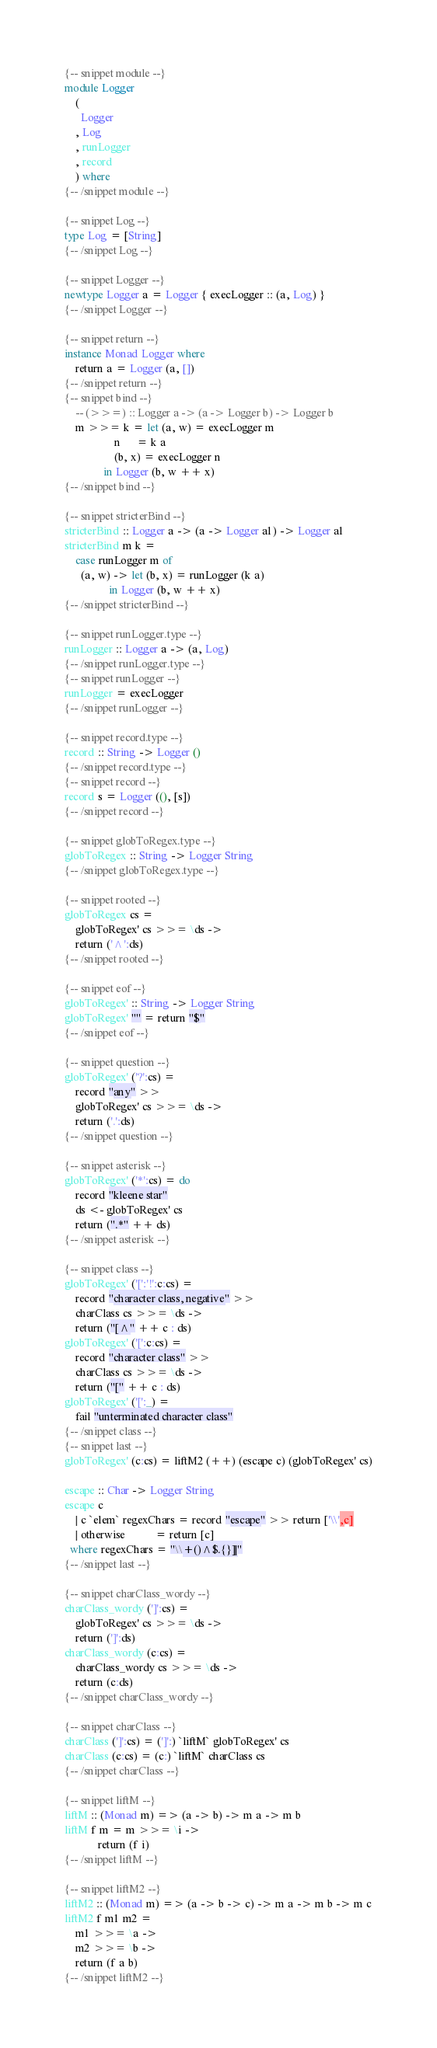Convert code to text. <code><loc_0><loc_0><loc_500><loc_500><_Haskell_>{-- snippet module --}
module Logger
    (
      Logger
    , Log
    , runLogger
    , record
    ) where
{-- /snippet module --}

{-- snippet Log --}
type Log = [String]
{-- /snippet Log --}

{-- snippet Logger --}
newtype Logger a = Logger { execLogger :: (a, Log) }
{-- /snippet Logger --}

{-- snippet return --}
instance Monad Logger where
    return a = Logger (a, [])
{-- /snippet return --}
{-- snippet bind --}
    -- (>>=) :: Logger a -> (a -> Logger b) -> Logger b
    m >>= k = let (a, w) = execLogger m
                  n      = k a
                  (b, x) = execLogger n
              in Logger (b, w ++ x)
{-- /snippet bind --}

{-- snippet stricterBind --}
stricterBind :: Logger a -> (a -> Logger a1) -> Logger a1
stricterBind m k =
    case runLogger m of
      (a, w) -> let (b, x) = runLogger (k a)
                in Logger (b, w ++ x)
{-- /snippet stricterBind --}

{-- snippet runLogger.type --}
runLogger :: Logger a -> (a, Log)
{-- /snippet runLogger.type --}
{-- snippet runLogger --}
runLogger = execLogger
{-- /snippet runLogger --}

{-- snippet record.type --}
record :: String -> Logger ()
{-- /snippet record.type --}
{-- snippet record --}
record s = Logger ((), [s])
{-- /snippet record --}

{-- snippet globToRegex.type --}
globToRegex :: String -> Logger String
{-- /snippet globToRegex.type --}

{-- snippet rooted --}
globToRegex cs =
    globToRegex' cs >>= \ds ->
    return ('^':ds)
{-- /snippet rooted --}

{-- snippet eof --}
globToRegex' :: String -> Logger String
globToRegex' "" = return "$"
{-- /snippet eof --}

{-- snippet question --}
globToRegex' ('?':cs) =
    record "any" >>
    globToRegex' cs >>= \ds ->
    return ('.':ds)
{-- /snippet question --}

{-- snippet asterisk --}
globToRegex' ('*':cs) = do
    record "kleene star"
    ds <- globToRegex' cs
    return (".*" ++ ds)
{-- /snippet asterisk --}

{-- snippet class --}
globToRegex' ('[':'!':c:cs) =
    record "character class, negative" >>
    charClass cs >>= \ds ->
    return ("[^" ++ c : ds)
globToRegex' ('[':c:cs) =
    record "character class" >>
    charClass cs >>= \ds ->
    return ("[" ++ c : ds)
globToRegex' ('[':_) =
    fail "unterminated character class"
{-- /snippet class --}
{-- snippet last --}
globToRegex' (c:cs) = liftM2 (++) (escape c) (globToRegex' cs)

escape :: Char -> Logger String
escape c
    | c `elem` regexChars = record "escape" >> return ['\\',c]
    | otherwise           = return [c]
  where regexChars = "\\+()^$.{}]|"
{-- /snippet last --}

{-- snippet charClass_wordy --}
charClass_wordy (']':cs) =
    globToRegex' cs >>= \ds ->
    return (']':ds)
charClass_wordy (c:cs) =
    charClass_wordy cs >>= \ds ->
    return (c:ds)
{-- /snippet charClass_wordy --}

{-- snippet charClass --}
charClass (']':cs) = (']':) `liftM` globToRegex' cs
charClass (c:cs) = (c:) `liftM` charClass cs
{-- /snippet charClass --}

{-- snippet liftM --}
liftM :: (Monad m) => (a -> b) -> m a -> m b
liftM f m = m >>= \i ->
            return (f i)
{-- /snippet liftM --}

{-- snippet liftM2 --}
liftM2 :: (Monad m) => (a -> b -> c) -> m a -> m b -> m c
liftM2 f m1 m2 =
    m1 >>= \a ->
    m2 >>= \b ->
    return (f a b)
{-- /snippet liftM2 --}
</code> 